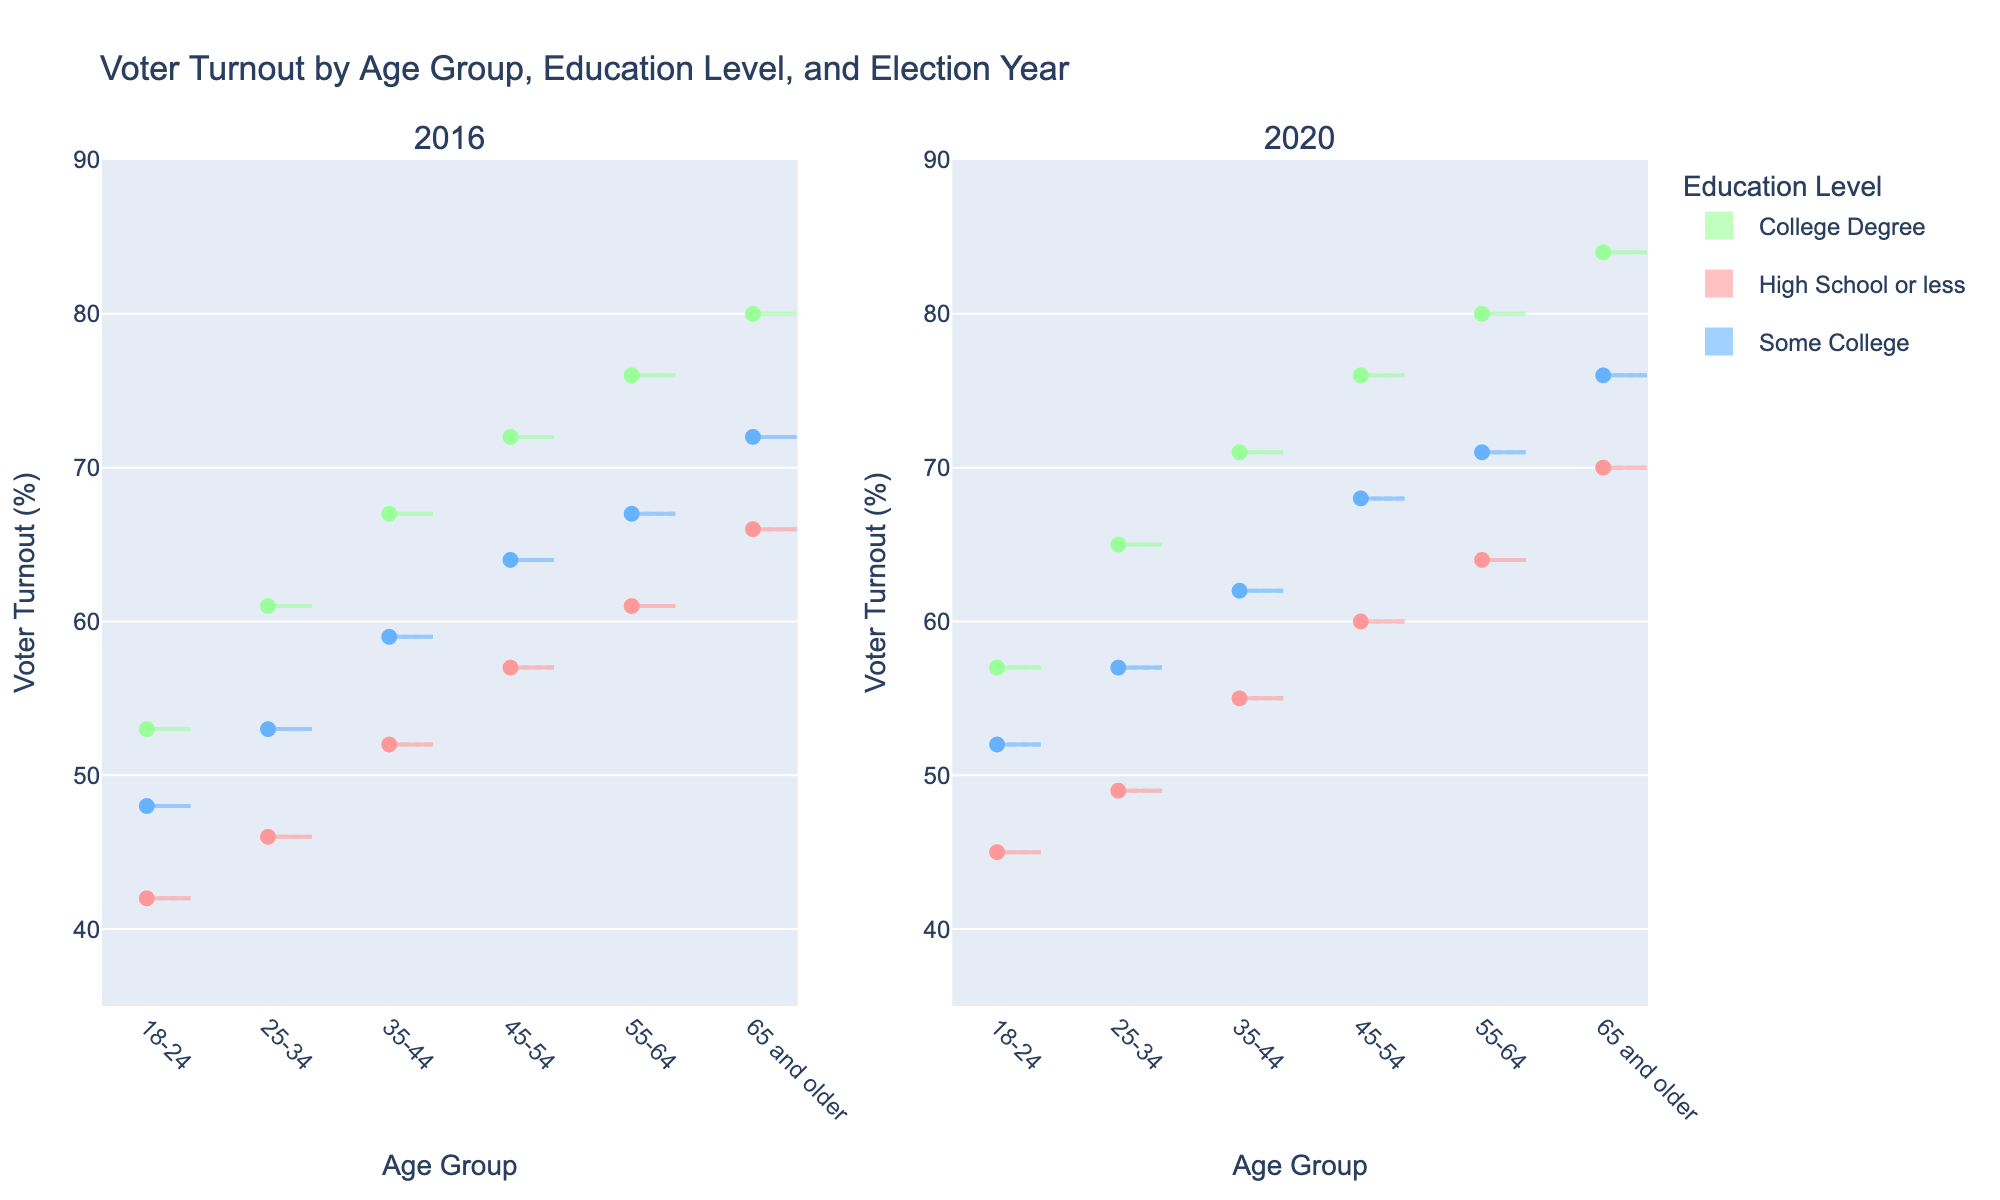what's the title of the figure? The title of the figure is located at the top and it clearly states what the figure represents. The title is "Voter Turnout by Age Group, Education Level, and Election Year".
Answer: Voter Turnout by Age Group, Education Level, and Election Year How does the Voter Turnout for the '18-24' age group with 'Some College' compare between 2016 and 2020? To answer this, locate the violin plots for '18-24' age group with 'Some College' education level in both the 2016 and 2020 sections. The turnout is 48% in 2016 and 52% in 2020, which means it increased from 2016 to 2020.
Answer: It increased from 48% to 52% What is the color used for the 'College Degree' education level? The plot legend indicates different colors for education levels. The color for 'College Degree' is a light green (seen in the violin plots and legend).
Answer: Light green Which age group has the highest voter turnout in 2020 among those with a 'High School or less' education level? Locate the 2020 section and focus on the 'High School or less' education level. Compare the voter turnout rates across all age groups. The highest turnout among these age groups is for '65 and older', with a turnout of 70%.
Answer: '65 and older' In the 2016 election, which age group and education level combination had the lowest voter turnout? Check the 2016 section and identify the lowest points in the violin plots. The '18-24' age group with 'High School or less' education level has the lowest voter turnout at 42%.
Answer: '18-24' with 'High School or less' On average, how much did the voter turnout increase from 2016 to 2020 for the 'College Degree' education level across all age groups? Compute the average increase by comparing the 2016 and 2020 voter turnout values for the 'College Degree' education level in each age group and then averaging the differences: [(57-53)+(65-61)+(71-67)+(76-72)+(80-76)+(84-80)]/6 = 4%.
Answer: 4% What pattern is observed in voter turnout with respect to education level across all age groups in the 2020 election? Examine the 2020 section. Higher education levels show higher voter turnout across all age groups. This pattern is evident since 'College Degree' has the highest turnout, followed by 'Some College', and lastly 'High School or less'.
Answer: Higher education levels correspond to higher voter turnout Which data point represents an outlier in voter turnout for the '55-64' age group with 'Some College' education level in 2020? Outliers in violin plots are typically the points far from the bulk of the distribution. In the '55-64' age group with 'Some College' in 2020, no data points visibly show an extreme deviation, hence there are no significant outliers.
Answer: No significant outliers How does the shape of the violin plot for the '45-54' age group in 2016 reflect its voter turnout distribution across different education levels? The shape of the violin plot indicates the density and distribution of data. For the '45-54' age group in 2016, the violin plots for different education levels show dense centers, particularly at the higher end for 'Some College' and 'College Degree', indicating most voters turnout is concentrated around higher percentages.
Answer: Dense at higher percentages for 'Some College' and 'College Degree' Which combination of age group and education level showed the most significant increase in voter turnout between 2016 and 2020? Compare the differences in voter turnout for each age group and education level combination between 2016 and 2020. The '55-64' age group with 'Some College' education level showed a significant increase from 67% in 2016 to 71% in 2020.
Answer: '55-64' with 'Some College' 